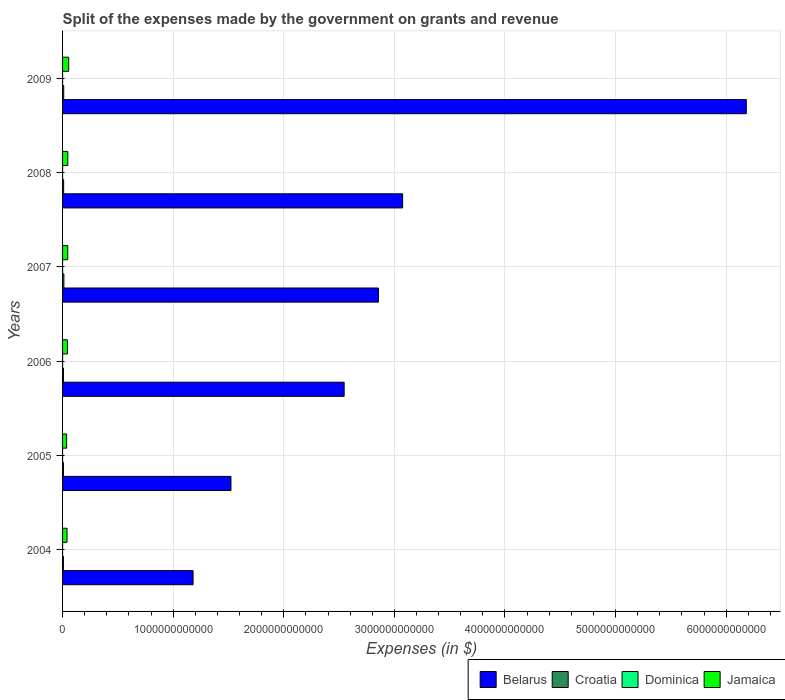How many different coloured bars are there?
Make the answer very short. 4. Are the number of bars per tick equal to the number of legend labels?
Make the answer very short. Yes. How many bars are there on the 1st tick from the top?
Give a very brief answer. 4. How many bars are there on the 4th tick from the bottom?
Keep it short and to the point. 4. In how many cases, is the number of bars for a given year not equal to the number of legend labels?
Provide a short and direct response. 0. What is the expenses made by the government on grants and revenue in Dominica in 2007?
Provide a succinct answer. 8.40e+07. Across all years, what is the maximum expenses made by the government on grants and revenue in Croatia?
Give a very brief answer. 1.19e+1. Across all years, what is the minimum expenses made by the government on grants and revenue in Dominica?
Offer a terse response. 3.38e+07. In which year was the expenses made by the government on grants and revenue in Dominica maximum?
Provide a succinct answer. 2008. What is the total expenses made by the government on grants and revenue in Belarus in the graph?
Offer a very short reply. 1.74e+13. What is the difference between the expenses made by the government on grants and revenue in Jamaica in 2006 and that in 2009?
Provide a succinct answer. -1.15e+1. What is the difference between the expenses made by the government on grants and revenue in Dominica in 2005 and the expenses made by the government on grants and revenue in Jamaica in 2008?
Keep it short and to the point. -4.74e+1. What is the average expenses made by the government on grants and revenue in Croatia per year?
Provide a succinct answer. 9.29e+09. In the year 2004, what is the difference between the expenses made by the government on grants and revenue in Croatia and expenses made by the government on grants and revenue in Dominica?
Give a very brief answer. 7.64e+09. In how many years, is the expenses made by the government on grants and revenue in Croatia greater than 6000000000000 $?
Ensure brevity in your answer.  0. What is the ratio of the expenses made by the government on grants and revenue in Croatia in 2005 to that in 2006?
Offer a terse response. 0.98. Is the difference between the expenses made by the government on grants and revenue in Croatia in 2005 and 2007 greater than the difference between the expenses made by the government on grants and revenue in Dominica in 2005 and 2007?
Provide a succinct answer. No. What is the difference between the highest and the second highest expenses made by the government on grants and revenue in Croatia?
Provide a short and direct response. 1.53e+09. What is the difference between the highest and the lowest expenses made by the government on grants and revenue in Jamaica?
Your answer should be compact. 1.88e+1. What does the 4th bar from the top in 2007 represents?
Ensure brevity in your answer.  Belarus. What does the 4th bar from the bottom in 2009 represents?
Offer a terse response. Jamaica. Are all the bars in the graph horizontal?
Your response must be concise. Yes. How many years are there in the graph?
Make the answer very short. 6. What is the difference between two consecutive major ticks on the X-axis?
Provide a succinct answer. 1.00e+12. How many legend labels are there?
Provide a short and direct response. 4. How are the legend labels stacked?
Keep it short and to the point. Horizontal. What is the title of the graph?
Ensure brevity in your answer.  Split of the expenses made by the government on grants and revenue. What is the label or title of the X-axis?
Your answer should be compact. Expenses (in $). What is the label or title of the Y-axis?
Offer a terse response. Years. What is the Expenses (in $) in Belarus in 2004?
Provide a short and direct response. 1.18e+12. What is the Expenses (in $) of Croatia in 2004?
Provide a succinct answer. 7.71e+09. What is the Expenses (in $) of Dominica in 2004?
Provide a succinct answer. 6.56e+07. What is the Expenses (in $) of Jamaica in 2004?
Provide a short and direct response. 4.04e+1. What is the Expenses (in $) in Belarus in 2005?
Provide a short and direct response. 1.52e+12. What is the Expenses (in $) of Croatia in 2005?
Ensure brevity in your answer.  7.89e+09. What is the Expenses (in $) of Dominica in 2005?
Your answer should be compact. 3.38e+07. What is the Expenses (in $) in Jamaica in 2005?
Provide a short and direct response. 3.67e+1. What is the Expenses (in $) in Belarus in 2006?
Your answer should be very brief. 2.55e+12. What is the Expenses (in $) of Croatia in 2006?
Provide a succinct answer. 8.05e+09. What is the Expenses (in $) in Dominica in 2006?
Make the answer very short. 8.50e+07. What is the Expenses (in $) in Jamaica in 2006?
Your response must be concise. 4.41e+1. What is the Expenses (in $) of Belarus in 2007?
Offer a terse response. 2.86e+12. What is the Expenses (in $) of Croatia in 2007?
Offer a very short reply. 1.19e+1. What is the Expenses (in $) of Dominica in 2007?
Provide a short and direct response. 8.40e+07. What is the Expenses (in $) of Jamaica in 2007?
Make the answer very short. 4.69e+1. What is the Expenses (in $) in Belarus in 2008?
Give a very brief answer. 3.08e+12. What is the Expenses (in $) in Croatia in 2008?
Give a very brief answer. 9.76e+09. What is the Expenses (in $) of Dominica in 2008?
Your answer should be very brief. 1.09e+08. What is the Expenses (in $) in Jamaica in 2008?
Offer a very short reply. 4.75e+1. What is the Expenses (in $) of Belarus in 2009?
Offer a very short reply. 6.18e+12. What is the Expenses (in $) of Croatia in 2009?
Make the answer very short. 1.04e+1. What is the Expenses (in $) in Dominica in 2009?
Your response must be concise. 9.12e+07. What is the Expenses (in $) in Jamaica in 2009?
Offer a terse response. 5.55e+1. Across all years, what is the maximum Expenses (in $) of Belarus?
Provide a succinct answer. 6.18e+12. Across all years, what is the maximum Expenses (in $) of Croatia?
Offer a terse response. 1.19e+1. Across all years, what is the maximum Expenses (in $) of Dominica?
Give a very brief answer. 1.09e+08. Across all years, what is the maximum Expenses (in $) of Jamaica?
Provide a succinct answer. 5.55e+1. Across all years, what is the minimum Expenses (in $) of Belarus?
Make the answer very short. 1.18e+12. Across all years, what is the minimum Expenses (in $) of Croatia?
Your answer should be very brief. 7.71e+09. Across all years, what is the minimum Expenses (in $) of Dominica?
Give a very brief answer. 3.38e+07. Across all years, what is the minimum Expenses (in $) of Jamaica?
Give a very brief answer. 3.67e+1. What is the total Expenses (in $) of Belarus in the graph?
Ensure brevity in your answer.  1.74e+13. What is the total Expenses (in $) of Croatia in the graph?
Provide a succinct answer. 5.58e+1. What is the total Expenses (in $) of Dominica in the graph?
Ensure brevity in your answer.  4.68e+08. What is the total Expenses (in $) of Jamaica in the graph?
Offer a terse response. 2.71e+11. What is the difference between the Expenses (in $) in Belarus in 2004 and that in 2005?
Keep it short and to the point. -3.43e+11. What is the difference between the Expenses (in $) of Croatia in 2004 and that in 2005?
Offer a very short reply. -1.84e+08. What is the difference between the Expenses (in $) in Dominica in 2004 and that in 2005?
Provide a succinct answer. 3.18e+07. What is the difference between the Expenses (in $) of Jamaica in 2004 and that in 2005?
Make the answer very short. 3.68e+09. What is the difference between the Expenses (in $) of Belarus in 2004 and that in 2006?
Ensure brevity in your answer.  -1.37e+12. What is the difference between the Expenses (in $) of Croatia in 2004 and that in 2006?
Offer a terse response. -3.39e+08. What is the difference between the Expenses (in $) in Dominica in 2004 and that in 2006?
Ensure brevity in your answer.  -1.94e+07. What is the difference between the Expenses (in $) in Jamaica in 2004 and that in 2006?
Your answer should be very brief. -3.71e+09. What is the difference between the Expenses (in $) of Belarus in 2004 and that in 2007?
Offer a terse response. -1.68e+12. What is the difference between the Expenses (in $) of Croatia in 2004 and that in 2007?
Provide a short and direct response. -4.24e+09. What is the difference between the Expenses (in $) of Dominica in 2004 and that in 2007?
Your response must be concise. -1.84e+07. What is the difference between the Expenses (in $) in Jamaica in 2004 and that in 2007?
Your response must be concise. -6.54e+09. What is the difference between the Expenses (in $) of Belarus in 2004 and that in 2008?
Your response must be concise. -1.90e+12. What is the difference between the Expenses (in $) of Croatia in 2004 and that in 2008?
Your answer should be very brief. -2.05e+09. What is the difference between the Expenses (in $) in Dominica in 2004 and that in 2008?
Offer a very short reply. -4.30e+07. What is the difference between the Expenses (in $) in Jamaica in 2004 and that in 2008?
Provide a short and direct response. -7.10e+09. What is the difference between the Expenses (in $) in Belarus in 2004 and that in 2009?
Provide a short and direct response. -5.00e+12. What is the difference between the Expenses (in $) of Croatia in 2004 and that in 2009?
Your answer should be very brief. -2.71e+09. What is the difference between the Expenses (in $) in Dominica in 2004 and that in 2009?
Make the answer very short. -2.56e+07. What is the difference between the Expenses (in $) in Jamaica in 2004 and that in 2009?
Give a very brief answer. -1.52e+1. What is the difference between the Expenses (in $) in Belarus in 2005 and that in 2006?
Make the answer very short. -1.02e+12. What is the difference between the Expenses (in $) of Croatia in 2005 and that in 2006?
Keep it short and to the point. -1.55e+08. What is the difference between the Expenses (in $) in Dominica in 2005 and that in 2006?
Your answer should be very brief. -5.12e+07. What is the difference between the Expenses (in $) of Jamaica in 2005 and that in 2006?
Provide a succinct answer. -7.40e+09. What is the difference between the Expenses (in $) in Belarus in 2005 and that in 2007?
Your response must be concise. -1.33e+12. What is the difference between the Expenses (in $) of Croatia in 2005 and that in 2007?
Provide a short and direct response. -4.06e+09. What is the difference between the Expenses (in $) in Dominica in 2005 and that in 2007?
Provide a short and direct response. -5.02e+07. What is the difference between the Expenses (in $) of Jamaica in 2005 and that in 2007?
Offer a terse response. -1.02e+1. What is the difference between the Expenses (in $) of Belarus in 2005 and that in 2008?
Your answer should be very brief. -1.55e+12. What is the difference between the Expenses (in $) of Croatia in 2005 and that in 2008?
Ensure brevity in your answer.  -1.87e+09. What is the difference between the Expenses (in $) of Dominica in 2005 and that in 2008?
Your answer should be very brief. -7.48e+07. What is the difference between the Expenses (in $) in Jamaica in 2005 and that in 2008?
Ensure brevity in your answer.  -1.08e+1. What is the difference between the Expenses (in $) in Belarus in 2005 and that in 2009?
Your response must be concise. -4.66e+12. What is the difference between the Expenses (in $) of Croatia in 2005 and that in 2009?
Ensure brevity in your answer.  -2.52e+09. What is the difference between the Expenses (in $) of Dominica in 2005 and that in 2009?
Offer a terse response. -5.74e+07. What is the difference between the Expenses (in $) in Jamaica in 2005 and that in 2009?
Your answer should be very brief. -1.88e+1. What is the difference between the Expenses (in $) in Belarus in 2006 and that in 2007?
Provide a succinct answer. -3.10e+11. What is the difference between the Expenses (in $) in Croatia in 2006 and that in 2007?
Provide a short and direct response. -3.90e+09. What is the difference between the Expenses (in $) of Jamaica in 2006 and that in 2007?
Provide a short and direct response. -2.83e+09. What is the difference between the Expenses (in $) in Belarus in 2006 and that in 2008?
Your answer should be very brief. -5.29e+11. What is the difference between the Expenses (in $) of Croatia in 2006 and that in 2008?
Provide a short and direct response. -1.71e+09. What is the difference between the Expenses (in $) in Dominica in 2006 and that in 2008?
Provide a short and direct response. -2.36e+07. What is the difference between the Expenses (in $) of Jamaica in 2006 and that in 2008?
Make the answer very short. -3.39e+09. What is the difference between the Expenses (in $) of Belarus in 2006 and that in 2009?
Provide a short and direct response. -3.64e+12. What is the difference between the Expenses (in $) in Croatia in 2006 and that in 2009?
Provide a succinct answer. -2.37e+09. What is the difference between the Expenses (in $) of Dominica in 2006 and that in 2009?
Offer a very short reply. -6.20e+06. What is the difference between the Expenses (in $) of Jamaica in 2006 and that in 2009?
Your answer should be very brief. -1.15e+1. What is the difference between the Expenses (in $) of Belarus in 2007 and that in 2008?
Your answer should be compact. -2.19e+11. What is the difference between the Expenses (in $) in Croatia in 2007 and that in 2008?
Provide a succinct answer. 2.19e+09. What is the difference between the Expenses (in $) in Dominica in 2007 and that in 2008?
Your answer should be compact. -2.46e+07. What is the difference between the Expenses (in $) in Jamaica in 2007 and that in 2008?
Provide a succinct answer. -5.56e+08. What is the difference between the Expenses (in $) of Belarus in 2007 and that in 2009?
Your answer should be very brief. -3.33e+12. What is the difference between the Expenses (in $) of Croatia in 2007 and that in 2009?
Give a very brief answer. 1.53e+09. What is the difference between the Expenses (in $) of Dominica in 2007 and that in 2009?
Ensure brevity in your answer.  -7.20e+06. What is the difference between the Expenses (in $) in Jamaica in 2007 and that in 2009?
Make the answer very short. -8.62e+09. What is the difference between the Expenses (in $) of Belarus in 2008 and that in 2009?
Provide a succinct answer. -3.11e+12. What is the difference between the Expenses (in $) in Croatia in 2008 and that in 2009?
Provide a short and direct response. -6.52e+08. What is the difference between the Expenses (in $) of Dominica in 2008 and that in 2009?
Your response must be concise. 1.74e+07. What is the difference between the Expenses (in $) in Jamaica in 2008 and that in 2009?
Your answer should be compact. -8.07e+09. What is the difference between the Expenses (in $) of Belarus in 2004 and the Expenses (in $) of Croatia in 2005?
Offer a terse response. 1.17e+12. What is the difference between the Expenses (in $) in Belarus in 2004 and the Expenses (in $) in Dominica in 2005?
Your answer should be compact. 1.18e+12. What is the difference between the Expenses (in $) in Belarus in 2004 and the Expenses (in $) in Jamaica in 2005?
Your response must be concise. 1.14e+12. What is the difference between the Expenses (in $) in Croatia in 2004 and the Expenses (in $) in Dominica in 2005?
Your answer should be very brief. 7.67e+09. What is the difference between the Expenses (in $) in Croatia in 2004 and the Expenses (in $) in Jamaica in 2005?
Ensure brevity in your answer.  -2.90e+1. What is the difference between the Expenses (in $) of Dominica in 2004 and the Expenses (in $) of Jamaica in 2005?
Ensure brevity in your answer.  -3.66e+1. What is the difference between the Expenses (in $) in Belarus in 2004 and the Expenses (in $) in Croatia in 2006?
Your response must be concise. 1.17e+12. What is the difference between the Expenses (in $) of Belarus in 2004 and the Expenses (in $) of Dominica in 2006?
Offer a terse response. 1.18e+12. What is the difference between the Expenses (in $) of Belarus in 2004 and the Expenses (in $) of Jamaica in 2006?
Offer a very short reply. 1.14e+12. What is the difference between the Expenses (in $) of Croatia in 2004 and the Expenses (in $) of Dominica in 2006?
Your response must be concise. 7.62e+09. What is the difference between the Expenses (in $) in Croatia in 2004 and the Expenses (in $) in Jamaica in 2006?
Offer a terse response. -3.64e+1. What is the difference between the Expenses (in $) in Dominica in 2004 and the Expenses (in $) in Jamaica in 2006?
Ensure brevity in your answer.  -4.40e+1. What is the difference between the Expenses (in $) of Belarus in 2004 and the Expenses (in $) of Croatia in 2007?
Offer a terse response. 1.17e+12. What is the difference between the Expenses (in $) of Belarus in 2004 and the Expenses (in $) of Dominica in 2007?
Your answer should be compact. 1.18e+12. What is the difference between the Expenses (in $) in Belarus in 2004 and the Expenses (in $) in Jamaica in 2007?
Your response must be concise. 1.13e+12. What is the difference between the Expenses (in $) in Croatia in 2004 and the Expenses (in $) in Dominica in 2007?
Provide a short and direct response. 7.62e+09. What is the difference between the Expenses (in $) in Croatia in 2004 and the Expenses (in $) in Jamaica in 2007?
Your response must be concise. -3.92e+1. What is the difference between the Expenses (in $) in Dominica in 2004 and the Expenses (in $) in Jamaica in 2007?
Provide a succinct answer. -4.68e+1. What is the difference between the Expenses (in $) of Belarus in 2004 and the Expenses (in $) of Croatia in 2008?
Provide a short and direct response. 1.17e+12. What is the difference between the Expenses (in $) in Belarus in 2004 and the Expenses (in $) in Dominica in 2008?
Offer a very short reply. 1.18e+12. What is the difference between the Expenses (in $) of Belarus in 2004 and the Expenses (in $) of Jamaica in 2008?
Offer a terse response. 1.13e+12. What is the difference between the Expenses (in $) in Croatia in 2004 and the Expenses (in $) in Dominica in 2008?
Offer a very short reply. 7.60e+09. What is the difference between the Expenses (in $) of Croatia in 2004 and the Expenses (in $) of Jamaica in 2008?
Keep it short and to the point. -3.98e+1. What is the difference between the Expenses (in $) of Dominica in 2004 and the Expenses (in $) of Jamaica in 2008?
Your answer should be very brief. -4.74e+1. What is the difference between the Expenses (in $) in Belarus in 2004 and the Expenses (in $) in Croatia in 2009?
Your answer should be compact. 1.17e+12. What is the difference between the Expenses (in $) of Belarus in 2004 and the Expenses (in $) of Dominica in 2009?
Give a very brief answer. 1.18e+12. What is the difference between the Expenses (in $) of Belarus in 2004 and the Expenses (in $) of Jamaica in 2009?
Your response must be concise. 1.12e+12. What is the difference between the Expenses (in $) of Croatia in 2004 and the Expenses (in $) of Dominica in 2009?
Your answer should be very brief. 7.62e+09. What is the difference between the Expenses (in $) in Croatia in 2004 and the Expenses (in $) in Jamaica in 2009?
Ensure brevity in your answer.  -4.78e+1. What is the difference between the Expenses (in $) of Dominica in 2004 and the Expenses (in $) of Jamaica in 2009?
Your answer should be very brief. -5.55e+1. What is the difference between the Expenses (in $) in Belarus in 2005 and the Expenses (in $) in Croatia in 2006?
Your response must be concise. 1.51e+12. What is the difference between the Expenses (in $) in Belarus in 2005 and the Expenses (in $) in Dominica in 2006?
Provide a succinct answer. 1.52e+12. What is the difference between the Expenses (in $) in Belarus in 2005 and the Expenses (in $) in Jamaica in 2006?
Your answer should be compact. 1.48e+12. What is the difference between the Expenses (in $) of Croatia in 2005 and the Expenses (in $) of Dominica in 2006?
Provide a succinct answer. 7.81e+09. What is the difference between the Expenses (in $) in Croatia in 2005 and the Expenses (in $) in Jamaica in 2006?
Offer a very short reply. -3.62e+1. What is the difference between the Expenses (in $) in Dominica in 2005 and the Expenses (in $) in Jamaica in 2006?
Offer a terse response. -4.40e+1. What is the difference between the Expenses (in $) in Belarus in 2005 and the Expenses (in $) in Croatia in 2007?
Make the answer very short. 1.51e+12. What is the difference between the Expenses (in $) of Belarus in 2005 and the Expenses (in $) of Dominica in 2007?
Keep it short and to the point. 1.52e+12. What is the difference between the Expenses (in $) of Belarus in 2005 and the Expenses (in $) of Jamaica in 2007?
Make the answer very short. 1.48e+12. What is the difference between the Expenses (in $) in Croatia in 2005 and the Expenses (in $) in Dominica in 2007?
Ensure brevity in your answer.  7.81e+09. What is the difference between the Expenses (in $) in Croatia in 2005 and the Expenses (in $) in Jamaica in 2007?
Provide a short and direct response. -3.90e+1. What is the difference between the Expenses (in $) in Dominica in 2005 and the Expenses (in $) in Jamaica in 2007?
Your answer should be compact. -4.69e+1. What is the difference between the Expenses (in $) of Belarus in 2005 and the Expenses (in $) of Croatia in 2008?
Offer a very short reply. 1.51e+12. What is the difference between the Expenses (in $) in Belarus in 2005 and the Expenses (in $) in Dominica in 2008?
Make the answer very short. 1.52e+12. What is the difference between the Expenses (in $) of Belarus in 2005 and the Expenses (in $) of Jamaica in 2008?
Ensure brevity in your answer.  1.48e+12. What is the difference between the Expenses (in $) in Croatia in 2005 and the Expenses (in $) in Dominica in 2008?
Offer a terse response. 7.78e+09. What is the difference between the Expenses (in $) of Croatia in 2005 and the Expenses (in $) of Jamaica in 2008?
Ensure brevity in your answer.  -3.96e+1. What is the difference between the Expenses (in $) of Dominica in 2005 and the Expenses (in $) of Jamaica in 2008?
Your response must be concise. -4.74e+1. What is the difference between the Expenses (in $) of Belarus in 2005 and the Expenses (in $) of Croatia in 2009?
Your answer should be very brief. 1.51e+12. What is the difference between the Expenses (in $) in Belarus in 2005 and the Expenses (in $) in Dominica in 2009?
Your answer should be very brief. 1.52e+12. What is the difference between the Expenses (in $) of Belarus in 2005 and the Expenses (in $) of Jamaica in 2009?
Offer a very short reply. 1.47e+12. What is the difference between the Expenses (in $) in Croatia in 2005 and the Expenses (in $) in Dominica in 2009?
Give a very brief answer. 7.80e+09. What is the difference between the Expenses (in $) of Croatia in 2005 and the Expenses (in $) of Jamaica in 2009?
Provide a succinct answer. -4.76e+1. What is the difference between the Expenses (in $) in Dominica in 2005 and the Expenses (in $) in Jamaica in 2009?
Offer a terse response. -5.55e+1. What is the difference between the Expenses (in $) in Belarus in 2006 and the Expenses (in $) in Croatia in 2007?
Provide a succinct answer. 2.53e+12. What is the difference between the Expenses (in $) of Belarus in 2006 and the Expenses (in $) of Dominica in 2007?
Ensure brevity in your answer.  2.55e+12. What is the difference between the Expenses (in $) of Belarus in 2006 and the Expenses (in $) of Jamaica in 2007?
Provide a succinct answer. 2.50e+12. What is the difference between the Expenses (in $) of Croatia in 2006 and the Expenses (in $) of Dominica in 2007?
Keep it short and to the point. 7.96e+09. What is the difference between the Expenses (in $) in Croatia in 2006 and the Expenses (in $) in Jamaica in 2007?
Keep it short and to the point. -3.89e+1. What is the difference between the Expenses (in $) of Dominica in 2006 and the Expenses (in $) of Jamaica in 2007?
Your response must be concise. -4.68e+1. What is the difference between the Expenses (in $) in Belarus in 2006 and the Expenses (in $) in Croatia in 2008?
Keep it short and to the point. 2.54e+12. What is the difference between the Expenses (in $) of Belarus in 2006 and the Expenses (in $) of Dominica in 2008?
Offer a terse response. 2.55e+12. What is the difference between the Expenses (in $) in Belarus in 2006 and the Expenses (in $) in Jamaica in 2008?
Keep it short and to the point. 2.50e+12. What is the difference between the Expenses (in $) of Croatia in 2006 and the Expenses (in $) of Dominica in 2008?
Provide a succinct answer. 7.94e+09. What is the difference between the Expenses (in $) in Croatia in 2006 and the Expenses (in $) in Jamaica in 2008?
Offer a very short reply. -3.94e+1. What is the difference between the Expenses (in $) in Dominica in 2006 and the Expenses (in $) in Jamaica in 2008?
Give a very brief answer. -4.74e+1. What is the difference between the Expenses (in $) in Belarus in 2006 and the Expenses (in $) in Croatia in 2009?
Provide a short and direct response. 2.54e+12. What is the difference between the Expenses (in $) of Belarus in 2006 and the Expenses (in $) of Dominica in 2009?
Give a very brief answer. 2.55e+12. What is the difference between the Expenses (in $) in Belarus in 2006 and the Expenses (in $) in Jamaica in 2009?
Your answer should be very brief. 2.49e+12. What is the difference between the Expenses (in $) in Croatia in 2006 and the Expenses (in $) in Dominica in 2009?
Your answer should be very brief. 7.96e+09. What is the difference between the Expenses (in $) of Croatia in 2006 and the Expenses (in $) of Jamaica in 2009?
Your response must be concise. -4.75e+1. What is the difference between the Expenses (in $) in Dominica in 2006 and the Expenses (in $) in Jamaica in 2009?
Give a very brief answer. -5.54e+1. What is the difference between the Expenses (in $) of Belarus in 2007 and the Expenses (in $) of Croatia in 2008?
Ensure brevity in your answer.  2.85e+12. What is the difference between the Expenses (in $) of Belarus in 2007 and the Expenses (in $) of Dominica in 2008?
Give a very brief answer. 2.86e+12. What is the difference between the Expenses (in $) of Belarus in 2007 and the Expenses (in $) of Jamaica in 2008?
Provide a short and direct response. 2.81e+12. What is the difference between the Expenses (in $) in Croatia in 2007 and the Expenses (in $) in Dominica in 2008?
Your answer should be very brief. 1.18e+1. What is the difference between the Expenses (in $) of Croatia in 2007 and the Expenses (in $) of Jamaica in 2008?
Provide a short and direct response. -3.55e+1. What is the difference between the Expenses (in $) in Dominica in 2007 and the Expenses (in $) in Jamaica in 2008?
Provide a short and direct response. -4.74e+1. What is the difference between the Expenses (in $) of Belarus in 2007 and the Expenses (in $) of Croatia in 2009?
Give a very brief answer. 2.85e+12. What is the difference between the Expenses (in $) of Belarus in 2007 and the Expenses (in $) of Dominica in 2009?
Your response must be concise. 2.86e+12. What is the difference between the Expenses (in $) of Belarus in 2007 and the Expenses (in $) of Jamaica in 2009?
Make the answer very short. 2.80e+12. What is the difference between the Expenses (in $) in Croatia in 2007 and the Expenses (in $) in Dominica in 2009?
Make the answer very short. 1.19e+1. What is the difference between the Expenses (in $) of Croatia in 2007 and the Expenses (in $) of Jamaica in 2009?
Keep it short and to the point. -4.36e+1. What is the difference between the Expenses (in $) of Dominica in 2007 and the Expenses (in $) of Jamaica in 2009?
Your answer should be compact. -5.54e+1. What is the difference between the Expenses (in $) in Belarus in 2008 and the Expenses (in $) in Croatia in 2009?
Ensure brevity in your answer.  3.06e+12. What is the difference between the Expenses (in $) in Belarus in 2008 and the Expenses (in $) in Dominica in 2009?
Your answer should be very brief. 3.07e+12. What is the difference between the Expenses (in $) in Belarus in 2008 and the Expenses (in $) in Jamaica in 2009?
Your answer should be very brief. 3.02e+12. What is the difference between the Expenses (in $) of Croatia in 2008 and the Expenses (in $) of Dominica in 2009?
Your answer should be very brief. 9.67e+09. What is the difference between the Expenses (in $) in Croatia in 2008 and the Expenses (in $) in Jamaica in 2009?
Keep it short and to the point. -4.58e+1. What is the difference between the Expenses (in $) of Dominica in 2008 and the Expenses (in $) of Jamaica in 2009?
Make the answer very short. -5.54e+1. What is the average Expenses (in $) of Belarus per year?
Give a very brief answer. 2.89e+12. What is the average Expenses (in $) in Croatia per year?
Offer a terse response. 9.29e+09. What is the average Expenses (in $) in Dominica per year?
Offer a very short reply. 7.80e+07. What is the average Expenses (in $) in Jamaica per year?
Provide a succinct answer. 4.52e+1. In the year 2004, what is the difference between the Expenses (in $) of Belarus and Expenses (in $) of Croatia?
Ensure brevity in your answer.  1.17e+12. In the year 2004, what is the difference between the Expenses (in $) of Belarus and Expenses (in $) of Dominica?
Make the answer very short. 1.18e+12. In the year 2004, what is the difference between the Expenses (in $) of Belarus and Expenses (in $) of Jamaica?
Your answer should be compact. 1.14e+12. In the year 2004, what is the difference between the Expenses (in $) in Croatia and Expenses (in $) in Dominica?
Give a very brief answer. 7.64e+09. In the year 2004, what is the difference between the Expenses (in $) in Croatia and Expenses (in $) in Jamaica?
Your response must be concise. -3.27e+1. In the year 2004, what is the difference between the Expenses (in $) in Dominica and Expenses (in $) in Jamaica?
Your response must be concise. -4.03e+1. In the year 2005, what is the difference between the Expenses (in $) of Belarus and Expenses (in $) of Croatia?
Your answer should be very brief. 1.51e+12. In the year 2005, what is the difference between the Expenses (in $) of Belarus and Expenses (in $) of Dominica?
Provide a short and direct response. 1.52e+12. In the year 2005, what is the difference between the Expenses (in $) of Belarus and Expenses (in $) of Jamaica?
Provide a succinct answer. 1.49e+12. In the year 2005, what is the difference between the Expenses (in $) of Croatia and Expenses (in $) of Dominica?
Your answer should be very brief. 7.86e+09. In the year 2005, what is the difference between the Expenses (in $) of Croatia and Expenses (in $) of Jamaica?
Provide a succinct answer. -2.88e+1. In the year 2005, what is the difference between the Expenses (in $) of Dominica and Expenses (in $) of Jamaica?
Your response must be concise. -3.66e+1. In the year 2006, what is the difference between the Expenses (in $) of Belarus and Expenses (in $) of Croatia?
Your answer should be compact. 2.54e+12. In the year 2006, what is the difference between the Expenses (in $) of Belarus and Expenses (in $) of Dominica?
Give a very brief answer. 2.55e+12. In the year 2006, what is the difference between the Expenses (in $) of Belarus and Expenses (in $) of Jamaica?
Provide a succinct answer. 2.50e+12. In the year 2006, what is the difference between the Expenses (in $) of Croatia and Expenses (in $) of Dominica?
Your answer should be very brief. 7.96e+09. In the year 2006, what is the difference between the Expenses (in $) of Croatia and Expenses (in $) of Jamaica?
Your response must be concise. -3.60e+1. In the year 2006, what is the difference between the Expenses (in $) of Dominica and Expenses (in $) of Jamaica?
Your answer should be compact. -4.40e+1. In the year 2007, what is the difference between the Expenses (in $) of Belarus and Expenses (in $) of Croatia?
Provide a short and direct response. 2.84e+12. In the year 2007, what is the difference between the Expenses (in $) of Belarus and Expenses (in $) of Dominica?
Your response must be concise. 2.86e+12. In the year 2007, what is the difference between the Expenses (in $) in Belarus and Expenses (in $) in Jamaica?
Your response must be concise. 2.81e+12. In the year 2007, what is the difference between the Expenses (in $) of Croatia and Expenses (in $) of Dominica?
Provide a succinct answer. 1.19e+1. In the year 2007, what is the difference between the Expenses (in $) in Croatia and Expenses (in $) in Jamaica?
Make the answer very short. -3.50e+1. In the year 2007, what is the difference between the Expenses (in $) of Dominica and Expenses (in $) of Jamaica?
Make the answer very short. -4.68e+1. In the year 2008, what is the difference between the Expenses (in $) of Belarus and Expenses (in $) of Croatia?
Offer a terse response. 3.07e+12. In the year 2008, what is the difference between the Expenses (in $) of Belarus and Expenses (in $) of Dominica?
Offer a very short reply. 3.07e+12. In the year 2008, what is the difference between the Expenses (in $) in Belarus and Expenses (in $) in Jamaica?
Provide a short and direct response. 3.03e+12. In the year 2008, what is the difference between the Expenses (in $) in Croatia and Expenses (in $) in Dominica?
Ensure brevity in your answer.  9.65e+09. In the year 2008, what is the difference between the Expenses (in $) of Croatia and Expenses (in $) of Jamaica?
Provide a short and direct response. -3.77e+1. In the year 2008, what is the difference between the Expenses (in $) of Dominica and Expenses (in $) of Jamaica?
Make the answer very short. -4.74e+1. In the year 2009, what is the difference between the Expenses (in $) of Belarus and Expenses (in $) of Croatia?
Offer a terse response. 6.17e+12. In the year 2009, what is the difference between the Expenses (in $) of Belarus and Expenses (in $) of Dominica?
Your response must be concise. 6.18e+12. In the year 2009, what is the difference between the Expenses (in $) in Belarus and Expenses (in $) in Jamaica?
Your response must be concise. 6.13e+12. In the year 2009, what is the difference between the Expenses (in $) in Croatia and Expenses (in $) in Dominica?
Make the answer very short. 1.03e+1. In the year 2009, what is the difference between the Expenses (in $) in Croatia and Expenses (in $) in Jamaica?
Ensure brevity in your answer.  -4.51e+1. In the year 2009, what is the difference between the Expenses (in $) of Dominica and Expenses (in $) of Jamaica?
Ensure brevity in your answer.  -5.54e+1. What is the ratio of the Expenses (in $) of Belarus in 2004 to that in 2005?
Provide a short and direct response. 0.78. What is the ratio of the Expenses (in $) in Croatia in 2004 to that in 2005?
Keep it short and to the point. 0.98. What is the ratio of the Expenses (in $) of Dominica in 2004 to that in 2005?
Make the answer very short. 1.94. What is the ratio of the Expenses (in $) in Jamaica in 2004 to that in 2005?
Provide a succinct answer. 1.1. What is the ratio of the Expenses (in $) of Belarus in 2004 to that in 2006?
Ensure brevity in your answer.  0.46. What is the ratio of the Expenses (in $) in Croatia in 2004 to that in 2006?
Provide a short and direct response. 0.96. What is the ratio of the Expenses (in $) in Dominica in 2004 to that in 2006?
Offer a very short reply. 0.77. What is the ratio of the Expenses (in $) in Jamaica in 2004 to that in 2006?
Offer a very short reply. 0.92. What is the ratio of the Expenses (in $) of Belarus in 2004 to that in 2007?
Your answer should be compact. 0.41. What is the ratio of the Expenses (in $) in Croatia in 2004 to that in 2007?
Provide a succinct answer. 0.65. What is the ratio of the Expenses (in $) of Dominica in 2004 to that in 2007?
Provide a short and direct response. 0.78. What is the ratio of the Expenses (in $) in Jamaica in 2004 to that in 2007?
Your answer should be compact. 0.86. What is the ratio of the Expenses (in $) in Belarus in 2004 to that in 2008?
Ensure brevity in your answer.  0.38. What is the ratio of the Expenses (in $) in Croatia in 2004 to that in 2008?
Your answer should be very brief. 0.79. What is the ratio of the Expenses (in $) of Dominica in 2004 to that in 2008?
Provide a succinct answer. 0.6. What is the ratio of the Expenses (in $) in Jamaica in 2004 to that in 2008?
Keep it short and to the point. 0.85. What is the ratio of the Expenses (in $) of Belarus in 2004 to that in 2009?
Your response must be concise. 0.19. What is the ratio of the Expenses (in $) in Croatia in 2004 to that in 2009?
Your answer should be very brief. 0.74. What is the ratio of the Expenses (in $) in Dominica in 2004 to that in 2009?
Your answer should be very brief. 0.72. What is the ratio of the Expenses (in $) of Jamaica in 2004 to that in 2009?
Give a very brief answer. 0.73. What is the ratio of the Expenses (in $) in Belarus in 2005 to that in 2006?
Your answer should be compact. 0.6. What is the ratio of the Expenses (in $) of Croatia in 2005 to that in 2006?
Your answer should be compact. 0.98. What is the ratio of the Expenses (in $) of Dominica in 2005 to that in 2006?
Your response must be concise. 0.4. What is the ratio of the Expenses (in $) of Jamaica in 2005 to that in 2006?
Give a very brief answer. 0.83. What is the ratio of the Expenses (in $) of Belarus in 2005 to that in 2007?
Offer a terse response. 0.53. What is the ratio of the Expenses (in $) of Croatia in 2005 to that in 2007?
Your answer should be very brief. 0.66. What is the ratio of the Expenses (in $) in Dominica in 2005 to that in 2007?
Your response must be concise. 0.4. What is the ratio of the Expenses (in $) in Jamaica in 2005 to that in 2007?
Your response must be concise. 0.78. What is the ratio of the Expenses (in $) in Belarus in 2005 to that in 2008?
Keep it short and to the point. 0.5. What is the ratio of the Expenses (in $) of Croatia in 2005 to that in 2008?
Your answer should be very brief. 0.81. What is the ratio of the Expenses (in $) of Dominica in 2005 to that in 2008?
Make the answer very short. 0.31. What is the ratio of the Expenses (in $) in Jamaica in 2005 to that in 2008?
Your answer should be very brief. 0.77. What is the ratio of the Expenses (in $) in Belarus in 2005 to that in 2009?
Offer a terse response. 0.25. What is the ratio of the Expenses (in $) of Croatia in 2005 to that in 2009?
Your answer should be compact. 0.76. What is the ratio of the Expenses (in $) in Dominica in 2005 to that in 2009?
Keep it short and to the point. 0.37. What is the ratio of the Expenses (in $) in Jamaica in 2005 to that in 2009?
Your response must be concise. 0.66. What is the ratio of the Expenses (in $) of Belarus in 2006 to that in 2007?
Ensure brevity in your answer.  0.89. What is the ratio of the Expenses (in $) of Croatia in 2006 to that in 2007?
Make the answer very short. 0.67. What is the ratio of the Expenses (in $) in Dominica in 2006 to that in 2007?
Provide a short and direct response. 1.01. What is the ratio of the Expenses (in $) in Jamaica in 2006 to that in 2007?
Provide a short and direct response. 0.94. What is the ratio of the Expenses (in $) of Belarus in 2006 to that in 2008?
Offer a very short reply. 0.83. What is the ratio of the Expenses (in $) of Croatia in 2006 to that in 2008?
Make the answer very short. 0.82. What is the ratio of the Expenses (in $) of Dominica in 2006 to that in 2008?
Offer a very short reply. 0.78. What is the ratio of the Expenses (in $) of Jamaica in 2006 to that in 2008?
Make the answer very short. 0.93. What is the ratio of the Expenses (in $) in Belarus in 2006 to that in 2009?
Give a very brief answer. 0.41. What is the ratio of the Expenses (in $) of Croatia in 2006 to that in 2009?
Make the answer very short. 0.77. What is the ratio of the Expenses (in $) of Dominica in 2006 to that in 2009?
Offer a very short reply. 0.93. What is the ratio of the Expenses (in $) of Jamaica in 2006 to that in 2009?
Your answer should be compact. 0.79. What is the ratio of the Expenses (in $) of Belarus in 2007 to that in 2008?
Provide a short and direct response. 0.93. What is the ratio of the Expenses (in $) of Croatia in 2007 to that in 2008?
Your response must be concise. 1.22. What is the ratio of the Expenses (in $) in Dominica in 2007 to that in 2008?
Ensure brevity in your answer.  0.77. What is the ratio of the Expenses (in $) of Jamaica in 2007 to that in 2008?
Give a very brief answer. 0.99. What is the ratio of the Expenses (in $) of Belarus in 2007 to that in 2009?
Offer a terse response. 0.46. What is the ratio of the Expenses (in $) in Croatia in 2007 to that in 2009?
Offer a very short reply. 1.15. What is the ratio of the Expenses (in $) in Dominica in 2007 to that in 2009?
Give a very brief answer. 0.92. What is the ratio of the Expenses (in $) of Jamaica in 2007 to that in 2009?
Your response must be concise. 0.84. What is the ratio of the Expenses (in $) in Belarus in 2008 to that in 2009?
Provide a short and direct response. 0.5. What is the ratio of the Expenses (in $) of Croatia in 2008 to that in 2009?
Ensure brevity in your answer.  0.94. What is the ratio of the Expenses (in $) of Dominica in 2008 to that in 2009?
Give a very brief answer. 1.19. What is the ratio of the Expenses (in $) in Jamaica in 2008 to that in 2009?
Ensure brevity in your answer.  0.85. What is the difference between the highest and the second highest Expenses (in $) in Belarus?
Offer a very short reply. 3.11e+12. What is the difference between the highest and the second highest Expenses (in $) in Croatia?
Your answer should be very brief. 1.53e+09. What is the difference between the highest and the second highest Expenses (in $) in Dominica?
Give a very brief answer. 1.74e+07. What is the difference between the highest and the second highest Expenses (in $) in Jamaica?
Your answer should be very brief. 8.07e+09. What is the difference between the highest and the lowest Expenses (in $) in Belarus?
Provide a short and direct response. 5.00e+12. What is the difference between the highest and the lowest Expenses (in $) of Croatia?
Provide a succinct answer. 4.24e+09. What is the difference between the highest and the lowest Expenses (in $) in Dominica?
Provide a succinct answer. 7.48e+07. What is the difference between the highest and the lowest Expenses (in $) of Jamaica?
Provide a short and direct response. 1.88e+1. 